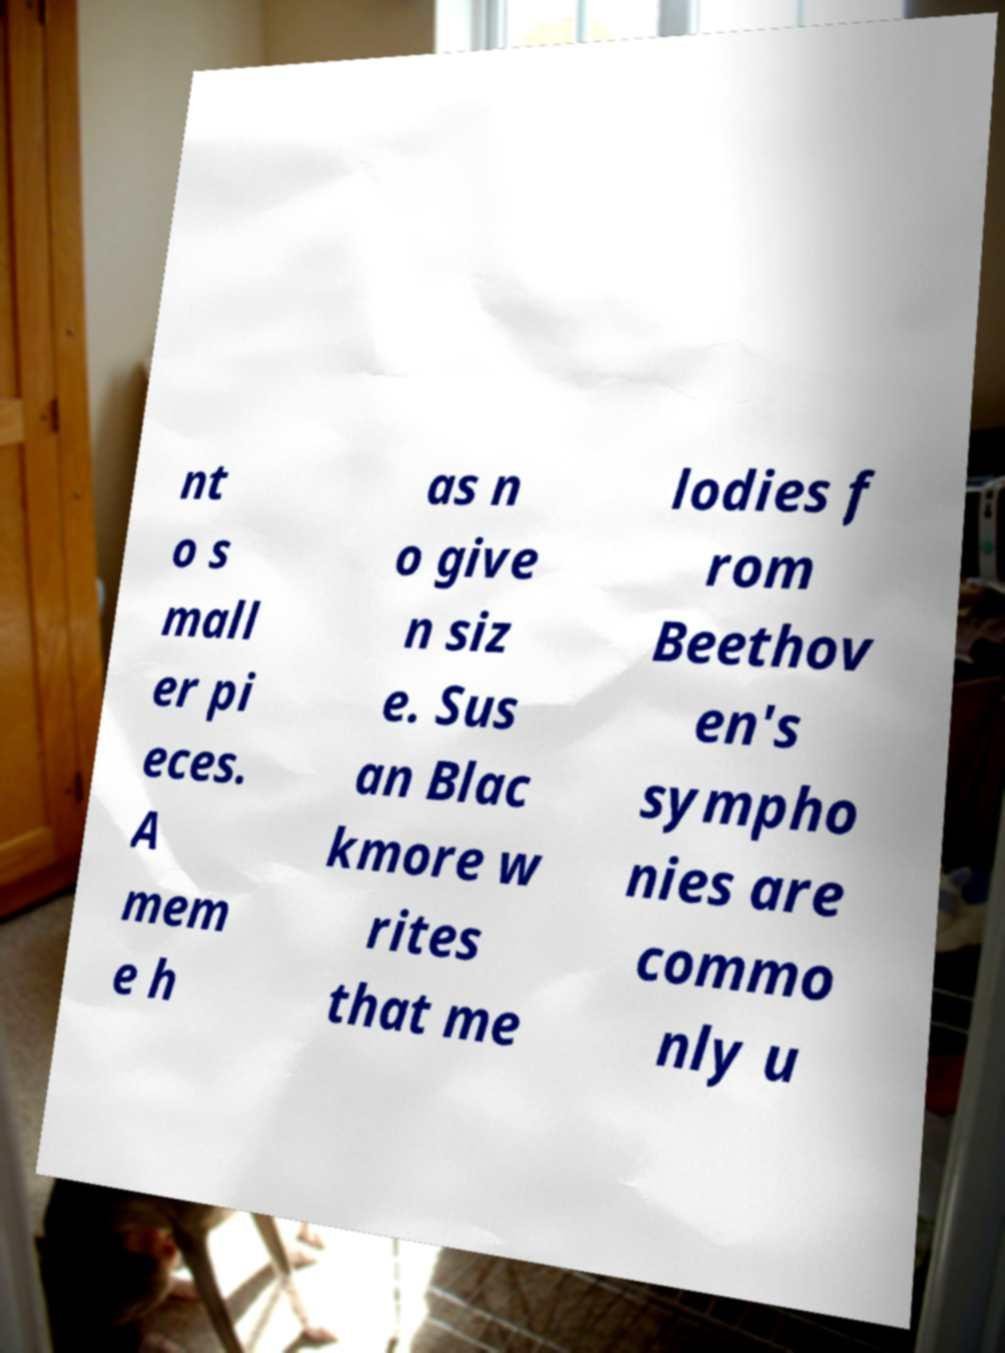There's text embedded in this image that I need extracted. Can you transcribe it verbatim? nt o s mall er pi eces. A mem e h as n o give n siz e. Sus an Blac kmore w rites that me lodies f rom Beethov en's sympho nies are commo nly u 